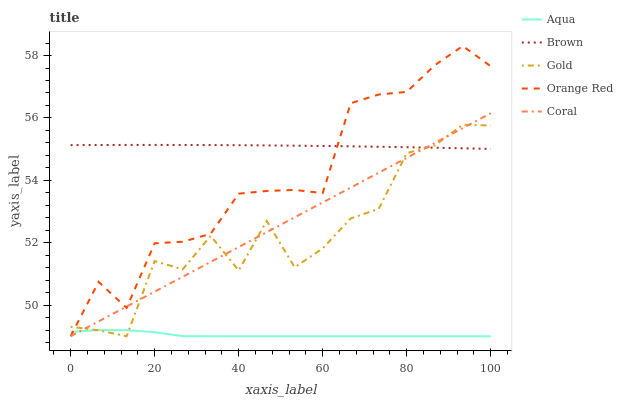Does Aqua have the minimum area under the curve?
Answer yes or no. Yes. Does Brown have the maximum area under the curve?
Answer yes or no. Yes. Does Coral have the minimum area under the curve?
Answer yes or no. No. Does Coral have the maximum area under the curve?
Answer yes or no. No. Is Coral the smoothest?
Answer yes or no. Yes. Is Gold the roughest?
Answer yes or no. Yes. Is Aqua the smoothest?
Answer yes or no. No. Is Aqua the roughest?
Answer yes or no. No. Does Coral have the lowest value?
Answer yes or no. Yes. Does Orange Red have the highest value?
Answer yes or no. Yes. Does Coral have the highest value?
Answer yes or no. No. Is Aqua less than Brown?
Answer yes or no. Yes. Is Brown greater than Aqua?
Answer yes or no. Yes. Does Gold intersect Brown?
Answer yes or no. Yes. Is Gold less than Brown?
Answer yes or no. No. Is Gold greater than Brown?
Answer yes or no. No. Does Aqua intersect Brown?
Answer yes or no. No. 